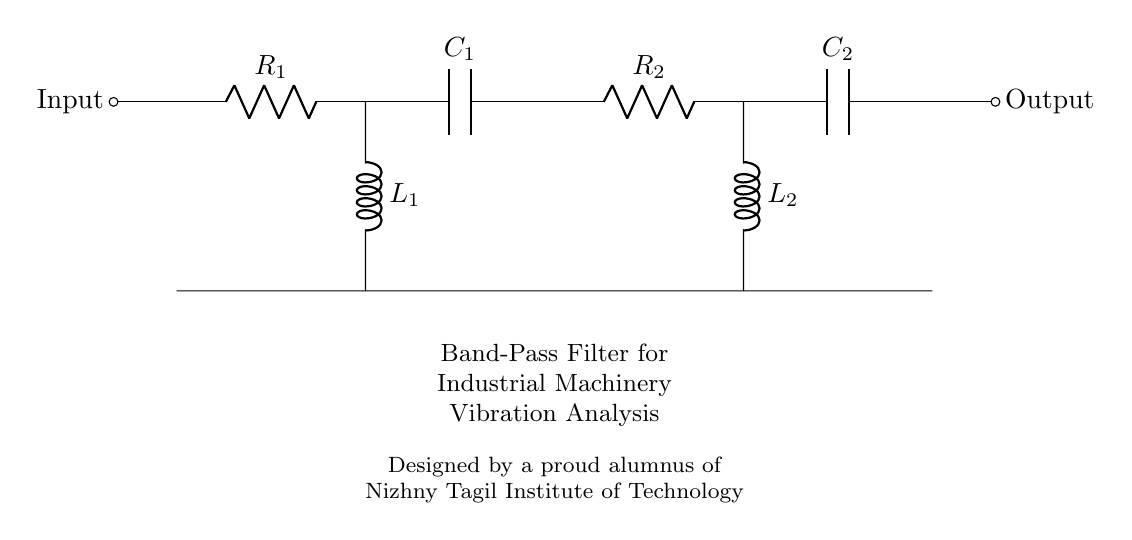What type of filter is represented in the circuit? The circuit shows a band-pass filter, which is characterized by its ability to allow signals within a certain frequency range to pass while attenuating signals outside that range.
Answer: band-pass filter How many resistors are present in the circuit? The circuit diagram indicates two resistors, labeled R1 and R2, which are essential components of the band-pass filter design.
Answer: two What is the role of the inductor in this circuit? The inductors L1 and L2 are integral to the band-pass filter's function, as they work with capacitors to define the frequency range that is allowed to pass through the filter, thus affecting the filter's behavior.
Answer: frequency tuning What is the input connection point labeled as? The input connection point is labeled "Input" in the diagram, making it clear where the external signal enters the band-pass filter circuit for analysis.
Answer: Input What does the output label indicate in this circuit? The output label indicates the point in the circuit where the processed signal exits after passing through the band-pass filter, highlighting where the analyzed vibrations can be measured or further processed.
Answer: Output How do capacitors contribute to the filter’s functionality? Capacitors C1 and C2 are critical in modulating the frequencies that can pass through the filter; they interact with the inductors and resistors to shape the frequency response of the circuit and determine the bandwidth of the signal.
Answer: frequency shaping What is the significance of labeling in a circuit diagram? Labeling, such as R1, C1, and the input/output designations, helps in identifying components and understanding their functions within the circuit, facilitating easier analysis and troubleshooting of the filter.
Answer: component identification 